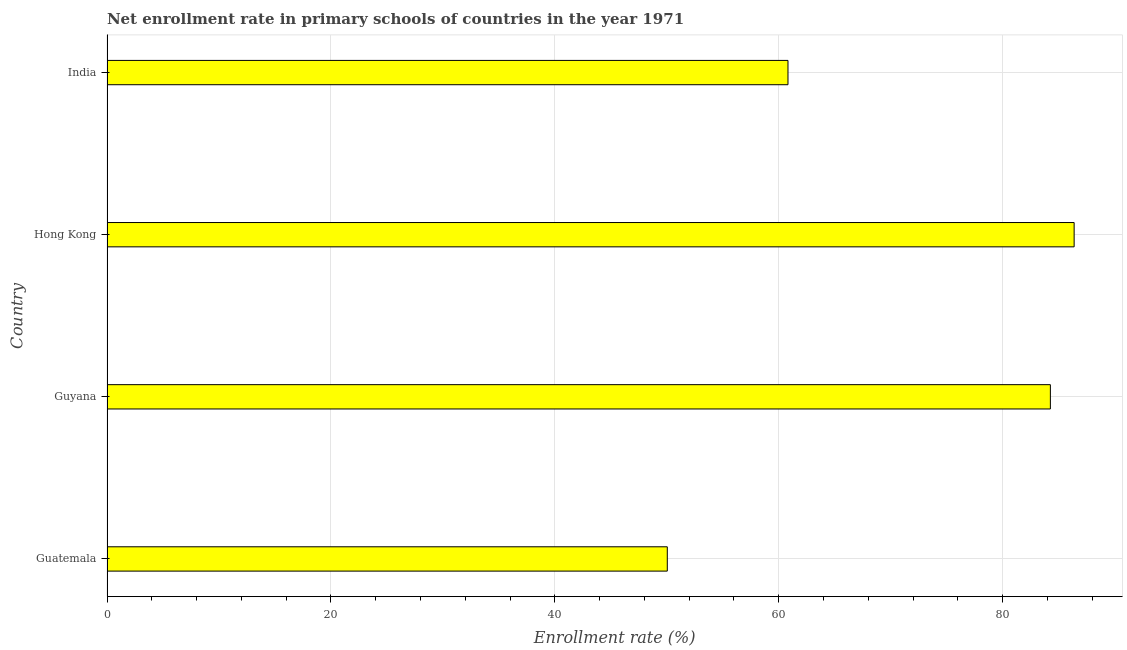Does the graph contain any zero values?
Offer a very short reply. No. What is the title of the graph?
Offer a very short reply. Net enrollment rate in primary schools of countries in the year 1971. What is the label or title of the X-axis?
Make the answer very short. Enrollment rate (%). What is the label or title of the Y-axis?
Provide a succinct answer. Country. What is the net enrollment rate in primary schools in Guyana?
Offer a very short reply. 84.27. Across all countries, what is the maximum net enrollment rate in primary schools?
Keep it short and to the point. 86.39. Across all countries, what is the minimum net enrollment rate in primary schools?
Offer a terse response. 50.05. In which country was the net enrollment rate in primary schools maximum?
Offer a terse response. Hong Kong. In which country was the net enrollment rate in primary schools minimum?
Your answer should be compact. Guatemala. What is the sum of the net enrollment rate in primary schools?
Your answer should be very brief. 281.53. What is the difference between the net enrollment rate in primary schools in Guatemala and Guyana?
Offer a terse response. -34.22. What is the average net enrollment rate in primary schools per country?
Offer a very short reply. 70.38. What is the median net enrollment rate in primary schools?
Offer a very short reply. 72.55. In how many countries, is the net enrollment rate in primary schools greater than 16 %?
Ensure brevity in your answer.  4. What is the ratio of the net enrollment rate in primary schools in Guyana to that in Hong Kong?
Give a very brief answer. 0.97. Is the difference between the net enrollment rate in primary schools in Hong Kong and India greater than the difference between any two countries?
Your answer should be very brief. No. What is the difference between the highest and the second highest net enrollment rate in primary schools?
Offer a very short reply. 2.12. What is the difference between the highest and the lowest net enrollment rate in primary schools?
Provide a succinct answer. 36.34. In how many countries, is the net enrollment rate in primary schools greater than the average net enrollment rate in primary schools taken over all countries?
Provide a short and direct response. 2. How many bars are there?
Keep it short and to the point. 4. What is the difference between two consecutive major ticks on the X-axis?
Offer a terse response. 20. Are the values on the major ticks of X-axis written in scientific E-notation?
Provide a short and direct response. No. What is the Enrollment rate (%) in Guatemala?
Give a very brief answer. 50.05. What is the Enrollment rate (%) in Guyana?
Provide a succinct answer. 84.27. What is the Enrollment rate (%) of Hong Kong?
Offer a very short reply. 86.39. What is the Enrollment rate (%) in India?
Ensure brevity in your answer.  60.83. What is the difference between the Enrollment rate (%) in Guatemala and Guyana?
Your answer should be compact. -34.22. What is the difference between the Enrollment rate (%) in Guatemala and Hong Kong?
Keep it short and to the point. -36.34. What is the difference between the Enrollment rate (%) in Guatemala and India?
Make the answer very short. -10.78. What is the difference between the Enrollment rate (%) in Guyana and Hong Kong?
Provide a succinct answer. -2.12. What is the difference between the Enrollment rate (%) in Guyana and India?
Your response must be concise. 23.44. What is the difference between the Enrollment rate (%) in Hong Kong and India?
Your answer should be very brief. 25.56. What is the ratio of the Enrollment rate (%) in Guatemala to that in Guyana?
Provide a short and direct response. 0.59. What is the ratio of the Enrollment rate (%) in Guatemala to that in Hong Kong?
Your answer should be compact. 0.58. What is the ratio of the Enrollment rate (%) in Guatemala to that in India?
Your answer should be very brief. 0.82. What is the ratio of the Enrollment rate (%) in Guyana to that in India?
Give a very brief answer. 1.39. What is the ratio of the Enrollment rate (%) in Hong Kong to that in India?
Keep it short and to the point. 1.42. 